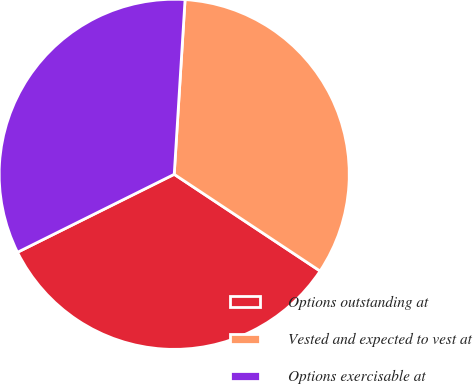Convert chart. <chart><loc_0><loc_0><loc_500><loc_500><pie_chart><fcel>Options outstanding at<fcel>Vested and expected to vest at<fcel>Options exercisable at<nl><fcel>33.33%<fcel>33.33%<fcel>33.33%<nl></chart> 